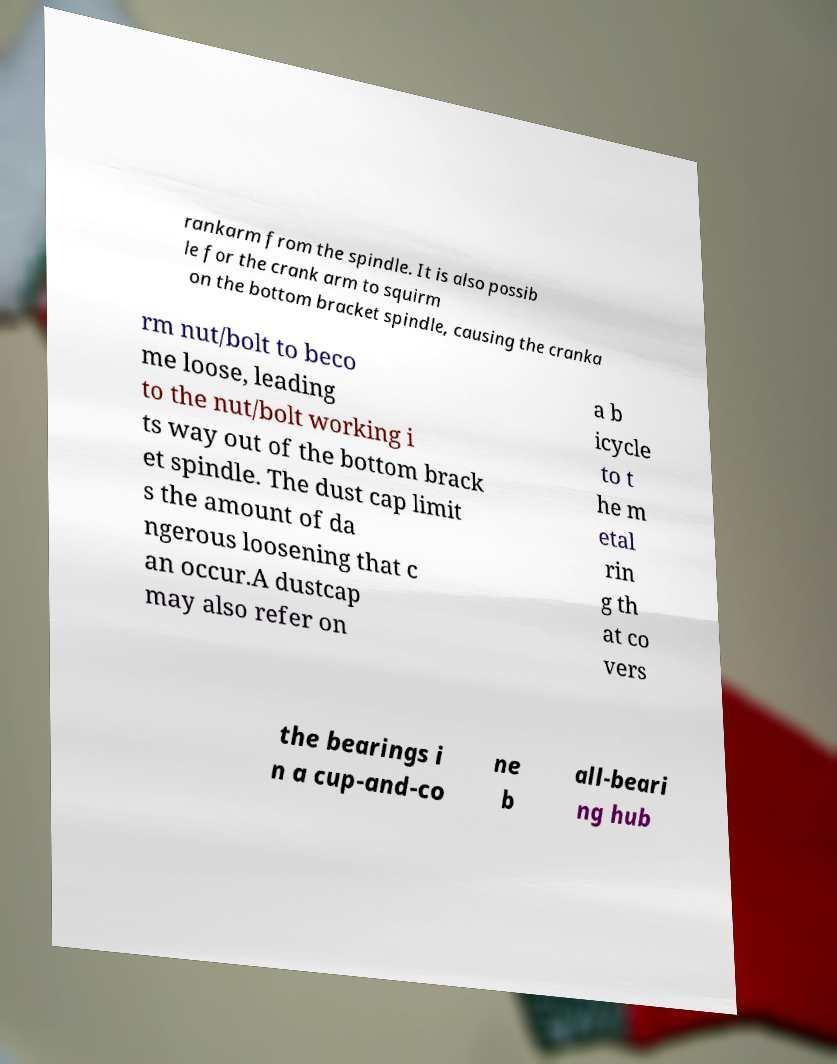There's text embedded in this image that I need extracted. Can you transcribe it verbatim? rankarm from the spindle. It is also possib le for the crank arm to squirm on the bottom bracket spindle, causing the cranka rm nut/bolt to beco me loose, leading to the nut/bolt working i ts way out of the bottom brack et spindle. The dust cap limit s the amount of da ngerous loosening that c an occur.A dustcap may also refer on a b icycle to t he m etal rin g th at co vers the bearings i n a cup-and-co ne b all-beari ng hub 